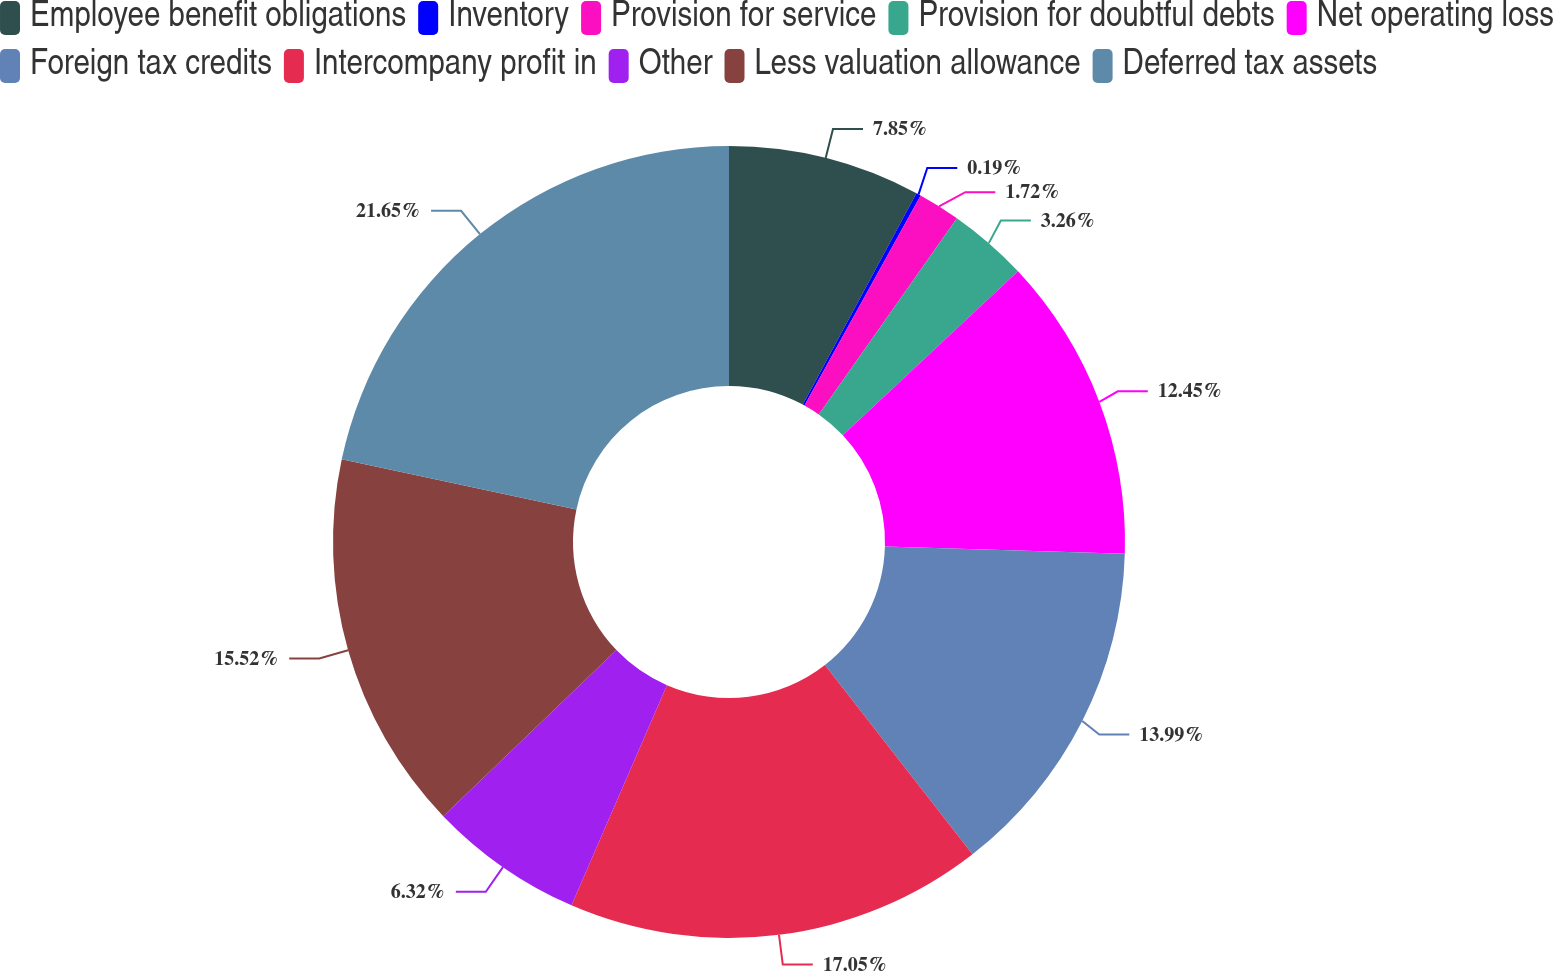Convert chart to OTSL. <chart><loc_0><loc_0><loc_500><loc_500><pie_chart><fcel>Employee benefit obligations<fcel>Inventory<fcel>Provision for service<fcel>Provision for doubtful debts<fcel>Net operating loss<fcel>Foreign tax credits<fcel>Intercompany profit in<fcel>Other<fcel>Less valuation allowance<fcel>Deferred tax assets<nl><fcel>7.85%<fcel>0.19%<fcel>1.72%<fcel>3.26%<fcel>12.45%<fcel>13.99%<fcel>17.05%<fcel>6.32%<fcel>15.52%<fcel>21.65%<nl></chart> 